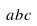Convert formula to latex. <formula><loc_0><loc_0><loc_500><loc_500>a b c</formula> 